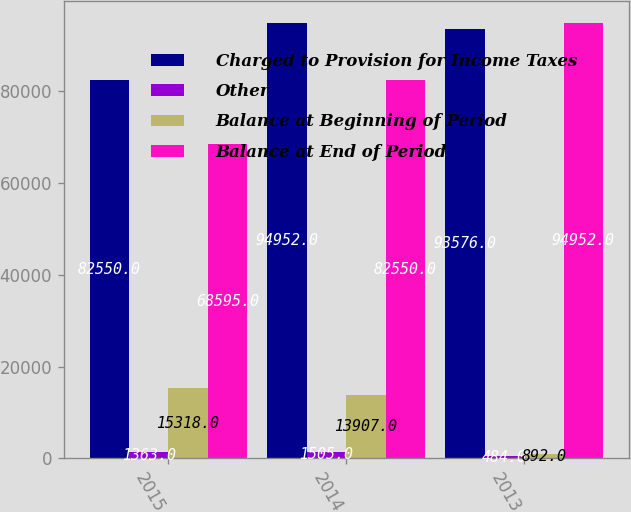<chart> <loc_0><loc_0><loc_500><loc_500><stacked_bar_chart><ecel><fcel>2015<fcel>2014<fcel>2013<nl><fcel>Charged to Provision for Income Taxes<fcel>82550<fcel>94952<fcel>93576<nl><fcel>Other<fcel>1363<fcel>1505<fcel>484<nl><fcel>Balance at Beginning of Period<fcel>15318<fcel>13907<fcel>892<nl><fcel>Balance at End of Period<fcel>68595<fcel>82550<fcel>94952<nl></chart> 